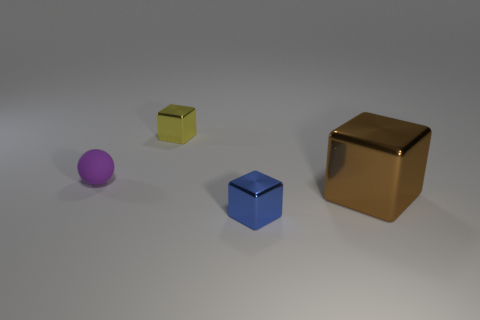Subtract all tiny cubes. How many cubes are left? 1 Add 3 tiny yellow objects. How many objects exist? 7 Subtract all yellow cubes. How many cubes are left? 2 Subtract all balls. How many objects are left? 3 Subtract 0 purple blocks. How many objects are left? 4 Subtract 1 blocks. How many blocks are left? 2 Subtract all brown cubes. Subtract all purple cylinders. How many cubes are left? 2 Subtract all green balls. How many brown blocks are left? 1 Subtract all blue objects. Subtract all small yellow objects. How many objects are left? 2 Add 2 big brown shiny things. How many big brown shiny things are left? 3 